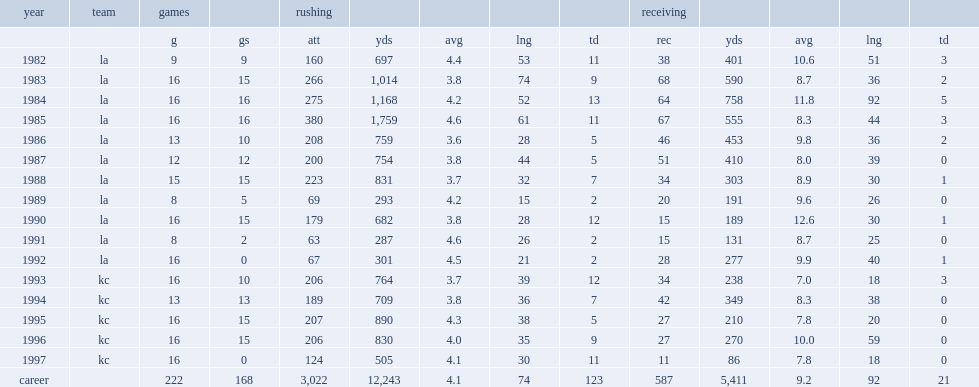How many rushing yards did allen get in his career? 12243.0. How many rushing touchdowns did marcus allen throw in total. 123.0. 